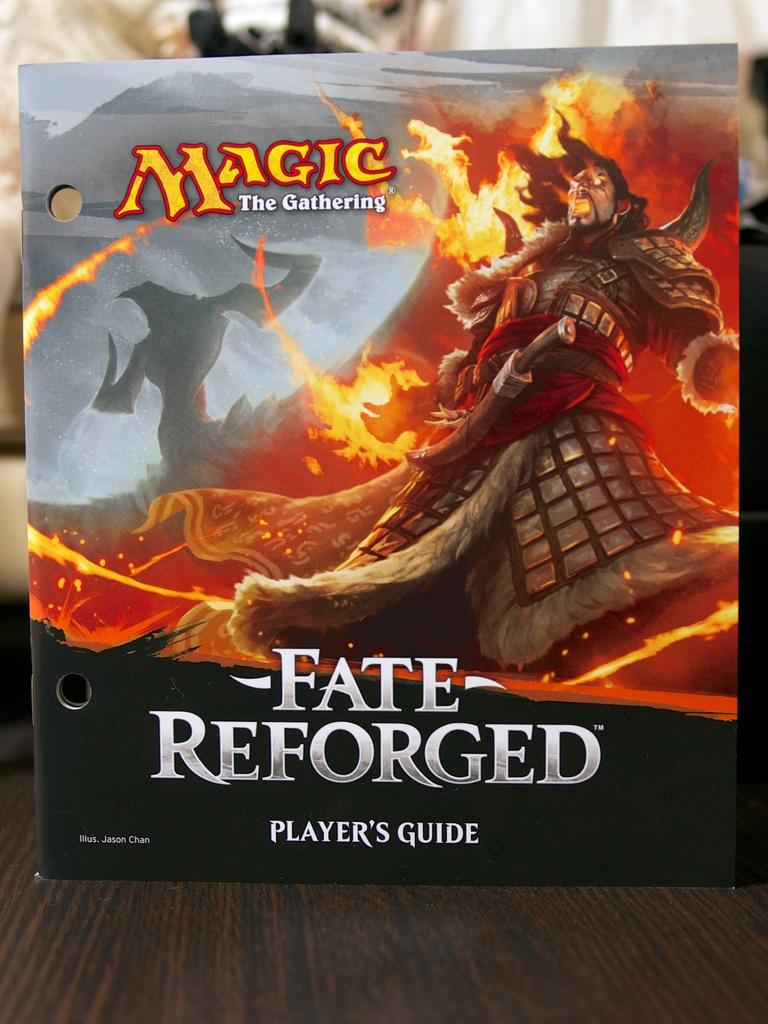Provide a one-sentence caption for the provided image. The player's guide for Fate Reforged shows a man surrounded by fire. 